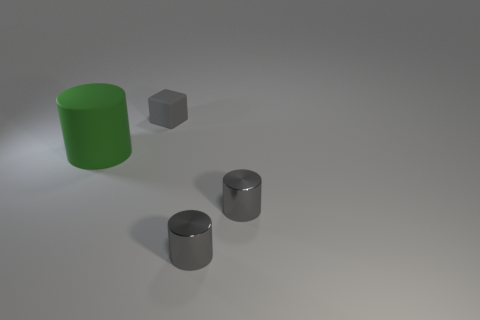Is the number of gray rubber objects that are in front of the big thing the same as the number of tiny metallic cylinders?
Make the answer very short. No. Is there a cylinder that is on the right side of the cylinder on the left side of the cube that is on the right side of the big green matte object?
Your answer should be compact. Yes. What is the material of the small block?
Offer a very short reply. Rubber. How many other things are there of the same shape as the large green matte object?
Offer a terse response. 2. How many objects are either rubber objects that are on the left side of the small matte block or cylinders that are on the right side of the matte cylinder?
Offer a terse response. 3. How many objects are green cylinders or gray metallic cylinders?
Offer a terse response. 3. There is a matte thing that is behind the big cylinder; what number of things are to the left of it?
Provide a short and direct response. 1. What number of other things are there of the same size as the green matte thing?
Offer a very short reply. 0. Is there a large thing that has the same material as the gray cube?
Offer a very short reply. Yes. What is the size of the cube?
Your response must be concise. Small. 